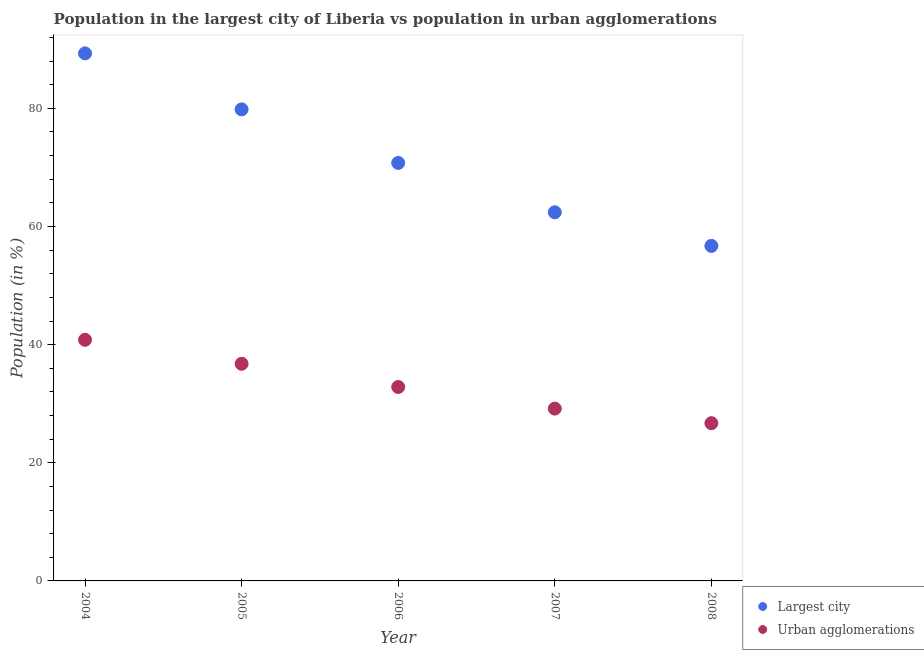How many different coloured dotlines are there?
Keep it short and to the point. 2. Is the number of dotlines equal to the number of legend labels?
Provide a short and direct response. Yes. What is the population in urban agglomerations in 2004?
Provide a succinct answer. 40.82. Across all years, what is the maximum population in the largest city?
Provide a succinct answer. 89.31. Across all years, what is the minimum population in urban agglomerations?
Ensure brevity in your answer.  26.71. In which year was the population in urban agglomerations maximum?
Provide a short and direct response. 2004. In which year was the population in the largest city minimum?
Make the answer very short. 2008. What is the total population in the largest city in the graph?
Ensure brevity in your answer.  359.03. What is the difference between the population in urban agglomerations in 2004 and that in 2008?
Offer a very short reply. 14.11. What is the difference between the population in the largest city in 2007 and the population in urban agglomerations in 2008?
Ensure brevity in your answer.  35.7. What is the average population in the largest city per year?
Offer a terse response. 71.81. In the year 2006, what is the difference between the population in urban agglomerations and population in the largest city?
Make the answer very short. -37.93. What is the ratio of the population in urban agglomerations in 2006 to that in 2008?
Make the answer very short. 1.23. What is the difference between the highest and the second highest population in urban agglomerations?
Offer a very short reply. 4.06. What is the difference between the highest and the lowest population in urban agglomerations?
Provide a short and direct response. 14.11. In how many years, is the population in urban agglomerations greater than the average population in urban agglomerations taken over all years?
Your answer should be very brief. 2. Is the sum of the population in urban agglomerations in 2004 and 2006 greater than the maximum population in the largest city across all years?
Offer a very short reply. No. Is the population in the largest city strictly less than the population in urban agglomerations over the years?
Ensure brevity in your answer.  No. Does the graph contain any zero values?
Offer a very short reply. No. Where does the legend appear in the graph?
Ensure brevity in your answer.  Bottom right. How are the legend labels stacked?
Provide a succinct answer. Vertical. What is the title of the graph?
Give a very brief answer. Population in the largest city of Liberia vs population in urban agglomerations. Does "Mineral" appear as one of the legend labels in the graph?
Provide a short and direct response. No. What is the label or title of the Y-axis?
Offer a very short reply. Population (in %). What is the Population (in %) in Largest city in 2004?
Ensure brevity in your answer.  89.31. What is the Population (in %) of Urban agglomerations in 2004?
Your answer should be compact. 40.82. What is the Population (in %) in Largest city in 2005?
Your answer should be very brief. 79.83. What is the Population (in %) of Urban agglomerations in 2005?
Ensure brevity in your answer.  36.76. What is the Population (in %) of Largest city in 2006?
Your answer should be compact. 70.77. What is the Population (in %) of Urban agglomerations in 2006?
Make the answer very short. 32.83. What is the Population (in %) of Largest city in 2007?
Ensure brevity in your answer.  62.41. What is the Population (in %) in Urban agglomerations in 2007?
Give a very brief answer. 29.17. What is the Population (in %) of Largest city in 2008?
Your answer should be compact. 56.72. What is the Population (in %) of Urban agglomerations in 2008?
Your answer should be compact. 26.71. Across all years, what is the maximum Population (in %) of Largest city?
Offer a very short reply. 89.31. Across all years, what is the maximum Population (in %) of Urban agglomerations?
Make the answer very short. 40.82. Across all years, what is the minimum Population (in %) of Largest city?
Offer a very short reply. 56.72. Across all years, what is the minimum Population (in %) of Urban agglomerations?
Your response must be concise. 26.71. What is the total Population (in %) in Largest city in the graph?
Offer a terse response. 359.03. What is the total Population (in %) in Urban agglomerations in the graph?
Keep it short and to the point. 166.29. What is the difference between the Population (in %) of Largest city in 2004 and that in 2005?
Ensure brevity in your answer.  9.48. What is the difference between the Population (in %) of Urban agglomerations in 2004 and that in 2005?
Offer a terse response. 4.06. What is the difference between the Population (in %) of Largest city in 2004 and that in 2006?
Give a very brief answer. 18.55. What is the difference between the Population (in %) of Urban agglomerations in 2004 and that in 2006?
Make the answer very short. 7.99. What is the difference between the Population (in %) in Largest city in 2004 and that in 2007?
Give a very brief answer. 26.91. What is the difference between the Population (in %) in Urban agglomerations in 2004 and that in 2007?
Keep it short and to the point. 11.65. What is the difference between the Population (in %) of Largest city in 2004 and that in 2008?
Offer a very short reply. 32.6. What is the difference between the Population (in %) in Urban agglomerations in 2004 and that in 2008?
Keep it short and to the point. 14.11. What is the difference between the Population (in %) of Largest city in 2005 and that in 2006?
Offer a very short reply. 9.06. What is the difference between the Population (in %) in Urban agglomerations in 2005 and that in 2006?
Give a very brief answer. 3.93. What is the difference between the Population (in %) of Largest city in 2005 and that in 2007?
Ensure brevity in your answer.  17.42. What is the difference between the Population (in %) of Urban agglomerations in 2005 and that in 2007?
Ensure brevity in your answer.  7.59. What is the difference between the Population (in %) in Largest city in 2005 and that in 2008?
Offer a very short reply. 23.11. What is the difference between the Population (in %) in Urban agglomerations in 2005 and that in 2008?
Make the answer very short. 10.06. What is the difference between the Population (in %) of Largest city in 2006 and that in 2007?
Offer a terse response. 8.36. What is the difference between the Population (in %) of Urban agglomerations in 2006 and that in 2007?
Offer a terse response. 3.66. What is the difference between the Population (in %) in Largest city in 2006 and that in 2008?
Keep it short and to the point. 14.05. What is the difference between the Population (in %) in Urban agglomerations in 2006 and that in 2008?
Offer a very short reply. 6.13. What is the difference between the Population (in %) in Largest city in 2007 and that in 2008?
Offer a terse response. 5.69. What is the difference between the Population (in %) of Urban agglomerations in 2007 and that in 2008?
Give a very brief answer. 2.46. What is the difference between the Population (in %) in Largest city in 2004 and the Population (in %) in Urban agglomerations in 2005?
Give a very brief answer. 52.55. What is the difference between the Population (in %) in Largest city in 2004 and the Population (in %) in Urban agglomerations in 2006?
Ensure brevity in your answer.  56.48. What is the difference between the Population (in %) of Largest city in 2004 and the Population (in %) of Urban agglomerations in 2007?
Offer a terse response. 60.14. What is the difference between the Population (in %) of Largest city in 2004 and the Population (in %) of Urban agglomerations in 2008?
Your answer should be very brief. 62.61. What is the difference between the Population (in %) in Largest city in 2005 and the Population (in %) in Urban agglomerations in 2006?
Provide a short and direct response. 47. What is the difference between the Population (in %) of Largest city in 2005 and the Population (in %) of Urban agglomerations in 2007?
Keep it short and to the point. 50.66. What is the difference between the Population (in %) in Largest city in 2005 and the Population (in %) in Urban agglomerations in 2008?
Provide a succinct answer. 53.12. What is the difference between the Population (in %) of Largest city in 2006 and the Population (in %) of Urban agglomerations in 2007?
Offer a terse response. 41.6. What is the difference between the Population (in %) of Largest city in 2006 and the Population (in %) of Urban agglomerations in 2008?
Offer a terse response. 44.06. What is the difference between the Population (in %) in Largest city in 2007 and the Population (in %) in Urban agglomerations in 2008?
Your answer should be very brief. 35.7. What is the average Population (in %) in Largest city per year?
Make the answer very short. 71.81. What is the average Population (in %) of Urban agglomerations per year?
Your answer should be very brief. 33.26. In the year 2004, what is the difference between the Population (in %) in Largest city and Population (in %) in Urban agglomerations?
Give a very brief answer. 48.49. In the year 2005, what is the difference between the Population (in %) in Largest city and Population (in %) in Urban agglomerations?
Give a very brief answer. 43.07. In the year 2006, what is the difference between the Population (in %) in Largest city and Population (in %) in Urban agglomerations?
Your answer should be compact. 37.93. In the year 2007, what is the difference between the Population (in %) of Largest city and Population (in %) of Urban agglomerations?
Make the answer very short. 33.24. In the year 2008, what is the difference between the Population (in %) of Largest city and Population (in %) of Urban agglomerations?
Provide a short and direct response. 30.01. What is the ratio of the Population (in %) in Largest city in 2004 to that in 2005?
Your answer should be compact. 1.12. What is the ratio of the Population (in %) of Urban agglomerations in 2004 to that in 2005?
Your response must be concise. 1.11. What is the ratio of the Population (in %) of Largest city in 2004 to that in 2006?
Offer a terse response. 1.26. What is the ratio of the Population (in %) in Urban agglomerations in 2004 to that in 2006?
Provide a succinct answer. 1.24. What is the ratio of the Population (in %) of Largest city in 2004 to that in 2007?
Your response must be concise. 1.43. What is the ratio of the Population (in %) in Urban agglomerations in 2004 to that in 2007?
Offer a terse response. 1.4. What is the ratio of the Population (in %) of Largest city in 2004 to that in 2008?
Ensure brevity in your answer.  1.57. What is the ratio of the Population (in %) in Urban agglomerations in 2004 to that in 2008?
Offer a very short reply. 1.53. What is the ratio of the Population (in %) of Largest city in 2005 to that in 2006?
Your answer should be compact. 1.13. What is the ratio of the Population (in %) in Urban agglomerations in 2005 to that in 2006?
Your response must be concise. 1.12. What is the ratio of the Population (in %) in Largest city in 2005 to that in 2007?
Provide a short and direct response. 1.28. What is the ratio of the Population (in %) in Urban agglomerations in 2005 to that in 2007?
Give a very brief answer. 1.26. What is the ratio of the Population (in %) in Largest city in 2005 to that in 2008?
Your answer should be very brief. 1.41. What is the ratio of the Population (in %) of Urban agglomerations in 2005 to that in 2008?
Offer a terse response. 1.38. What is the ratio of the Population (in %) in Largest city in 2006 to that in 2007?
Provide a succinct answer. 1.13. What is the ratio of the Population (in %) of Urban agglomerations in 2006 to that in 2007?
Make the answer very short. 1.13. What is the ratio of the Population (in %) of Largest city in 2006 to that in 2008?
Ensure brevity in your answer.  1.25. What is the ratio of the Population (in %) in Urban agglomerations in 2006 to that in 2008?
Give a very brief answer. 1.23. What is the ratio of the Population (in %) in Largest city in 2007 to that in 2008?
Offer a very short reply. 1.1. What is the ratio of the Population (in %) of Urban agglomerations in 2007 to that in 2008?
Keep it short and to the point. 1.09. What is the difference between the highest and the second highest Population (in %) in Largest city?
Make the answer very short. 9.48. What is the difference between the highest and the second highest Population (in %) in Urban agglomerations?
Provide a succinct answer. 4.06. What is the difference between the highest and the lowest Population (in %) in Largest city?
Your answer should be compact. 32.6. What is the difference between the highest and the lowest Population (in %) in Urban agglomerations?
Your response must be concise. 14.11. 